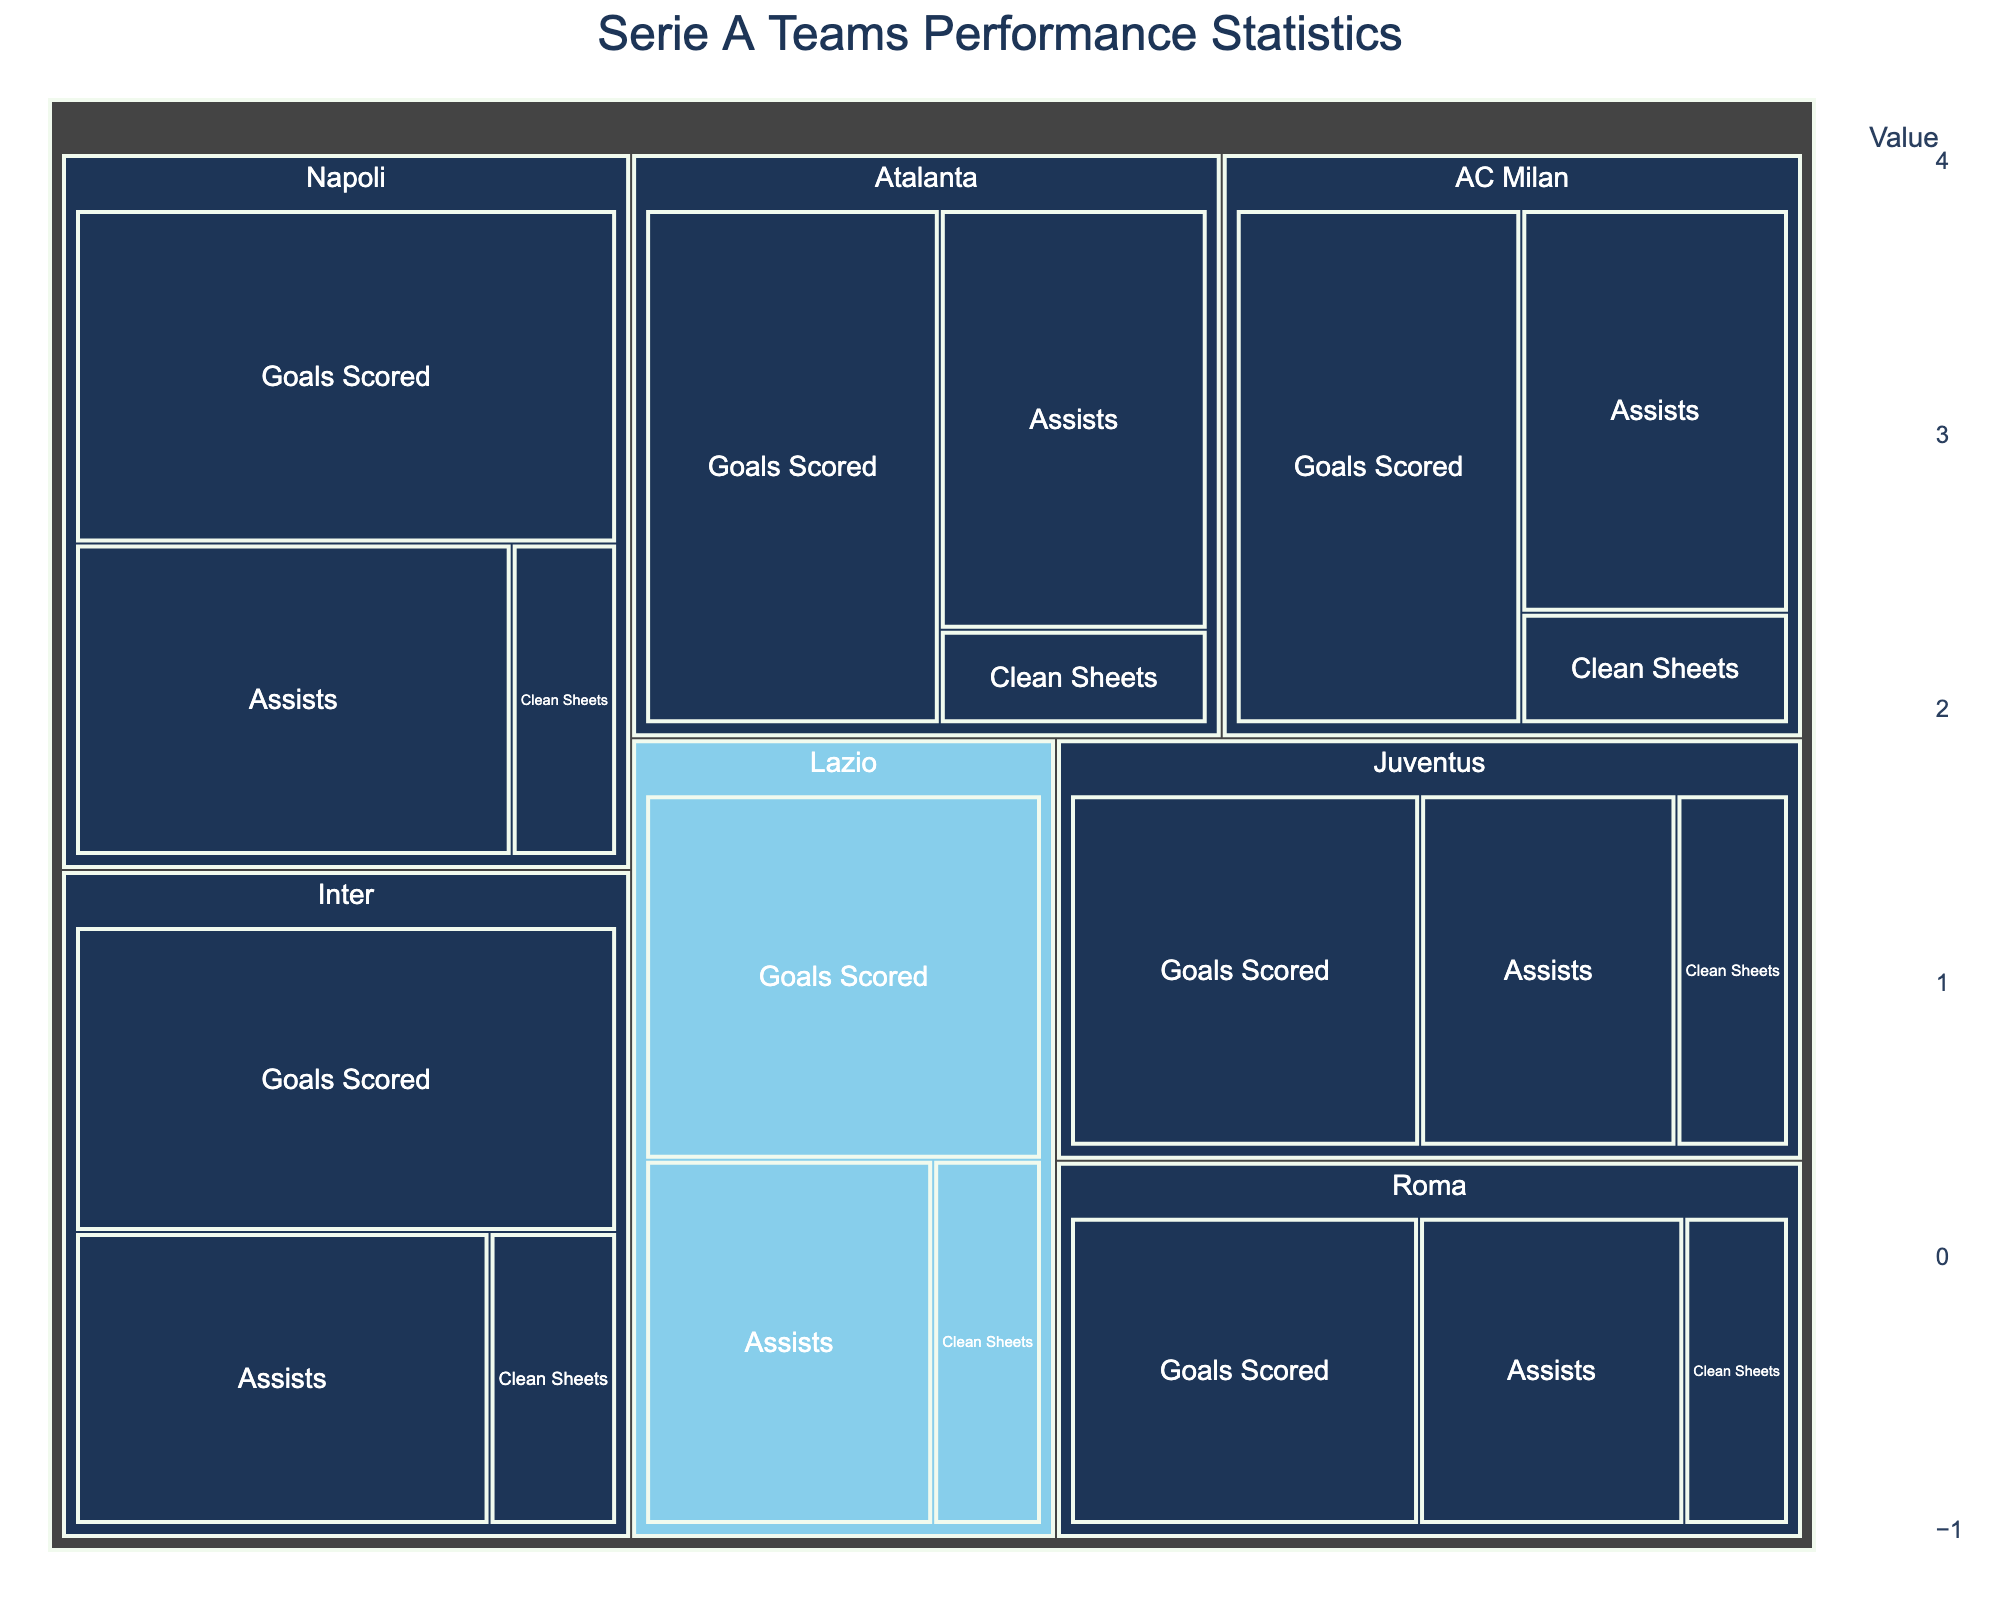What's the total number of goals scored by all teams combined? Add the goals scored by each team: Lazio (62), Napoli (77), Inter (71), AC Milan (64), Roma (50), Atalanta (66), and Juventus (56). The sum is 62 + 77 + 71 + 64 + 50 + 66 + 56 = 446
Answer: 446 Which team has the most clean sheets? Look for the team with the highest value in the "Clean Sheets" category. Juventus has 18 clean sheets, which is the highest value.
Answer: Juventus How does Lazio's number of assists compare to Roma's? Lazio has 45 assists while Roma has 38 assists. Lazio's number of assists is higher.
Answer: Lazio's assists are higher What is the average number of assists by the teams? Add all the assists: Lazio (45), Napoli (58), Inter (52), AC Milan (47), Roma (38), Atalanta (49), Juventus (41). Sum is 45 + 58 + 52 + 47 + 38 + 49 + 41 = 330. There are 7 teams, so average = 330 / 7 ≈ 47.14
Answer: 47.14 How many more goals did Atalanta score compared to Roma? Atalanta scored 66 goals, while Roma scored 50. The difference is 66 - 50 = 16
Answer: 16 Rank the teams by the number of clean sheets from highest to lowest. List the teams with their clean sheets: Juventus (18), Lazio (17), Inter (16), Roma (15), Napoli (14), AC Milan (13), Atalanta (11). Arrange in descending order.
Answer: Juventus, Lazio, Inter, Roma, Napoli, AC Milan, Atalanta Which team has the least goals scored? Look for the team with the lowest value in the "Goals Scored" category. Roma has the least goals scored with a value of 50.
Answer: Roma What is the sum of assists and clean sheets for Inter? Inter has 52 assists and 16 clean sheets. The sum is 52 + 16 = 68
Answer: 68 By how many does Lazio's clean sheets exceed AC Milan's clean sheets? Lazio has 17 clean sheets, and AC Milan has 13. The difference is 17 - 13 = 4
Answer: 4 